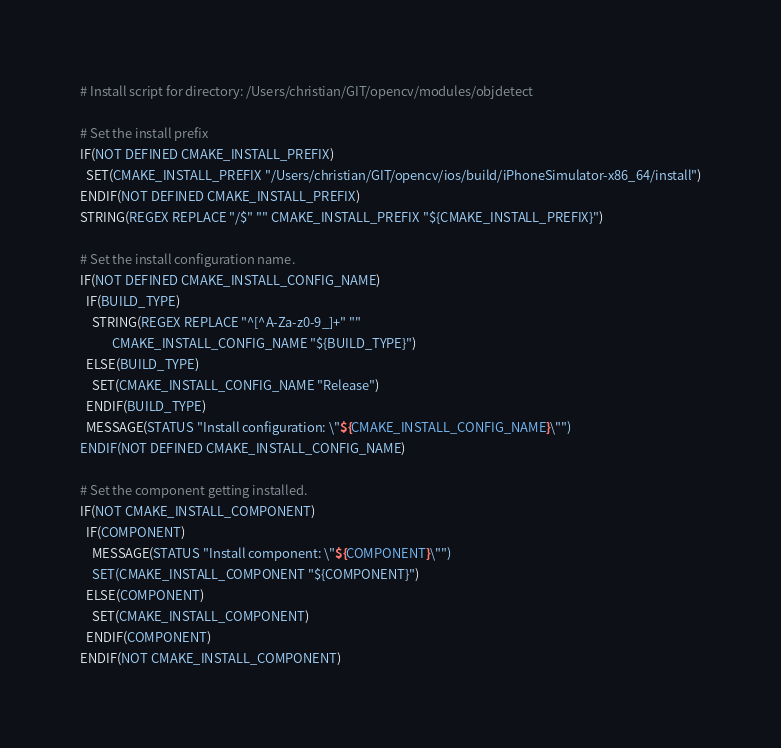Convert code to text. <code><loc_0><loc_0><loc_500><loc_500><_CMake_># Install script for directory: /Users/christian/GIT/opencv/modules/objdetect

# Set the install prefix
IF(NOT DEFINED CMAKE_INSTALL_PREFIX)
  SET(CMAKE_INSTALL_PREFIX "/Users/christian/GIT/opencv/ios/build/iPhoneSimulator-x86_64/install")
ENDIF(NOT DEFINED CMAKE_INSTALL_PREFIX)
STRING(REGEX REPLACE "/$" "" CMAKE_INSTALL_PREFIX "${CMAKE_INSTALL_PREFIX}")

# Set the install configuration name.
IF(NOT DEFINED CMAKE_INSTALL_CONFIG_NAME)
  IF(BUILD_TYPE)
    STRING(REGEX REPLACE "^[^A-Za-z0-9_]+" ""
           CMAKE_INSTALL_CONFIG_NAME "${BUILD_TYPE}")
  ELSE(BUILD_TYPE)
    SET(CMAKE_INSTALL_CONFIG_NAME "Release")
  ENDIF(BUILD_TYPE)
  MESSAGE(STATUS "Install configuration: \"${CMAKE_INSTALL_CONFIG_NAME}\"")
ENDIF(NOT DEFINED CMAKE_INSTALL_CONFIG_NAME)

# Set the component getting installed.
IF(NOT CMAKE_INSTALL_COMPONENT)
  IF(COMPONENT)
    MESSAGE(STATUS "Install component: \"${COMPONENT}\"")
    SET(CMAKE_INSTALL_COMPONENT "${COMPONENT}")
  ELSE(COMPONENT)
    SET(CMAKE_INSTALL_COMPONENT)
  ENDIF(COMPONENT)
ENDIF(NOT CMAKE_INSTALL_COMPONENT)

</code> 